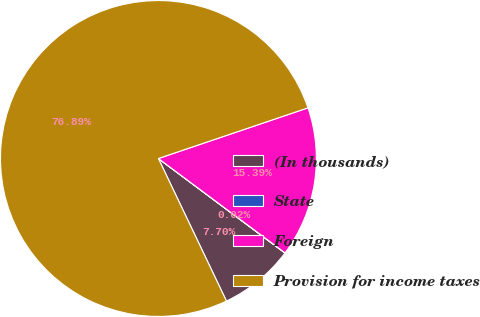Convert chart. <chart><loc_0><loc_0><loc_500><loc_500><pie_chart><fcel>(In thousands)<fcel>State<fcel>Foreign<fcel>Provision for income taxes<nl><fcel>7.7%<fcel>0.02%<fcel>15.39%<fcel>76.89%<nl></chart> 